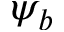<formula> <loc_0><loc_0><loc_500><loc_500>\psi _ { b }</formula> 